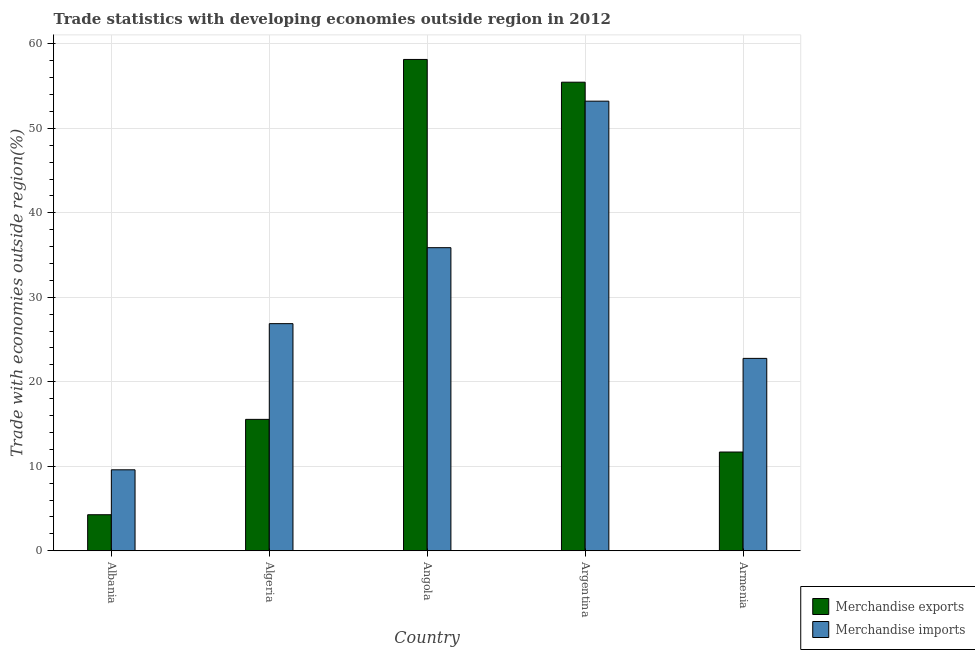Are the number of bars per tick equal to the number of legend labels?
Your answer should be compact. Yes. Are the number of bars on each tick of the X-axis equal?
Ensure brevity in your answer.  Yes. How many bars are there on the 4th tick from the left?
Offer a terse response. 2. What is the label of the 3rd group of bars from the left?
Give a very brief answer. Angola. What is the merchandise exports in Angola?
Your answer should be very brief. 58.15. Across all countries, what is the maximum merchandise exports?
Keep it short and to the point. 58.15. Across all countries, what is the minimum merchandise imports?
Your answer should be very brief. 9.58. In which country was the merchandise exports maximum?
Offer a very short reply. Angola. In which country was the merchandise imports minimum?
Provide a short and direct response. Albania. What is the total merchandise imports in the graph?
Keep it short and to the point. 148.32. What is the difference between the merchandise exports in Albania and that in Armenia?
Ensure brevity in your answer.  -7.42. What is the difference between the merchandise exports in Albania and the merchandise imports in Armenia?
Your answer should be compact. -18.5. What is the average merchandise imports per country?
Keep it short and to the point. 29.66. What is the difference between the merchandise exports and merchandise imports in Albania?
Your response must be concise. -5.32. In how many countries, is the merchandise exports greater than 22 %?
Provide a short and direct response. 2. What is the ratio of the merchandise exports in Angola to that in Argentina?
Offer a terse response. 1.05. Is the merchandise exports in Argentina less than that in Armenia?
Keep it short and to the point. No. Is the difference between the merchandise imports in Algeria and Argentina greater than the difference between the merchandise exports in Algeria and Argentina?
Provide a succinct answer. Yes. What is the difference between the highest and the second highest merchandise exports?
Your response must be concise. 2.69. What is the difference between the highest and the lowest merchandise imports?
Offer a very short reply. 43.63. Is the sum of the merchandise imports in Angola and Argentina greater than the maximum merchandise exports across all countries?
Ensure brevity in your answer.  Yes. How many countries are there in the graph?
Your answer should be compact. 5. What is the difference between two consecutive major ticks on the Y-axis?
Provide a succinct answer. 10. Are the values on the major ticks of Y-axis written in scientific E-notation?
Make the answer very short. No. Does the graph contain any zero values?
Give a very brief answer. No. Where does the legend appear in the graph?
Keep it short and to the point. Bottom right. How many legend labels are there?
Provide a succinct answer. 2. How are the legend labels stacked?
Make the answer very short. Vertical. What is the title of the graph?
Your response must be concise. Trade statistics with developing economies outside region in 2012. Does "Underweight" appear as one of the legend labels in the graph?
Ensure brevity in your answer.  No. What is the label or title of the X-axis?
Offer a terse response. Country. What is the label or title of the Y-axis?
Provide a short and direct response. Trade with economies outside region(%). What is the Trade with economies outside region(%) in Merchandise exports in Albania?
Give a very brief answer. 4.27. What is the Trade with economies outside region(%) of Merchandise imports in Albania?
Your response must be concise. 9.58. What is the Trade with economies outside region(%) in Merchandise exports in Algeria?
Your response must be concise. 15.55. What is the Trade with economies outside region(%) of Merchandise imports in Algeria?
Provide a succinct answer. 26.88. What is the Trade with economies outside region(%) in Merchandise exports in Angola?
Ensure brevity in your answer.  58.15. What is the Trade with economies outside region(%) of Merchandise imports in Angola?
Offer a terse response. 35.87. What is the Trade with economies outside region(%) of Merchandise exports in Argentina?
Ensure brevity in your answer.  55.46. What is the Trade with economies outside region(%) in Merchandise imports in Argentina?
Keep it short and to the point. 53.21. What is the Trade with economies outside region(%) of Merchandise exports in Armenia?
Give a very brief answer. 11.69. What is the Trade with economies outside region(%) of Merchandise imports in Armenia?
Provide a short and direct response. 22.77. Across all countries, what is the maximum Trade with economies outside region(%) in Merchandise exports?
Offer a terse response. 58.15. Across all countries, what is the maximum Trade with economies outside region(%) of Merchandise imports?
Keep it short and to the point. 53.21. Across all countries, what is the minimum Trade with economies outside region(%) of Merchandise exports?
Your answer should be very brief. 4.27. Across all countries, what is the minimum Trade with economies outside region(%) of Merchandise imports?
Make the answer very short. 9.58. What is the total Trade with economies outside region(%) of Merchandise exports in the graph?
Keep it short and to the point. 145.11. What is the total Trade with economies outside region(%) in Merchandise imports in the graph?
Your answer should be compact. 148.32. What is the difference between the Trade with economies outside region(%) of Merchandise exports in Albania and that in Algeria?
Provide a succinct answer. -11.29. What is the difference between the Trade with economies outside region(%) of Merchandise imports in Albania and that in Algeria?
Provide a succinct answer. -17.3. What is the difference between the Trade with economies outside region(%) in Merchandise exports in Albania and that in Angola?
Your response must be concise. -53.88. What is the difference between the Trade with economies outside region(%) of Merchandise imports in Albania and that in Angola?
Your answer should be very brief. -26.29. What is the difference between the Trade with economies outside region(%) of Merchandise exports in Albania and that in Argentina?
Ensure brevity in your answer.  -51.19. What is the difference between the Trade with economies outside region(%) of Merchandise imports in Albania and that in Argentina?
Provide a short and direct response. -43.63. What is the difference between the Trade with economies outside region(%) of Merchandise exports in Albania and that in Armenia?
Offer a terse response. -7.42. What is the difference between the Trade with economies outside region(%) in Merchandise imports in Albania and that in Armenia?
Your answer should be compact. -13.19. What is the difference between the Trade with economies outside region(%) in Merchandise exports in Algeria and that in Angola?
Offer a very short reply. -42.6. What is the difference between the Trade with economies outside region(%) in Merchandise imports in Algeria and that in Angola?
Your answer should be very brief. -8.99. What is the difference between the Trade with economies outside region(%) in Merchandise exports in Algeria and that in Argentina?
Make the answer very short. -39.91. What is the difference between the Trade with economies outside region(%) in Merchandise imports in Algeria and that in Argentina?
Your answer should be very brief. -26.33. What is the difference between the Trade with economies outside region(%) in Merchandise exports in Algeria and that in Armenia?
Offer a very short reply. 3.86. What is the difference between the Trade with economies outside region(%) in Merchandise imports in Algeria and that in Armenia?
Your response must be concise. 4.11. What is the difference between the Trade with economies outside region(%) of Merchandise exports in Angola and that in Argentina?
Your response must be concise. 2.69. What is the difference between the Trade with economies outside region(%) in Merchandise imports in Angola and that in Argentina?
Give a very brief answer. -17.34. What is the difference between the Trade with economies outside region(%) of Merchandise exports in Angola and that in Armenia?
Provide a short and direct response. 46.46. What is the difference between the Trade with economies outside region(%) in Merchandise imports in Angola and that in Armenia?
Your answer should be very brief. 13.1. What is the difference between the Trade with economies outside region(%) of Merchandise exports in Argentina and that in Armenia?
Provide a succinct answer. 43.77. What is the difference between the Trade with economies outside region(%) in Merchandise imports in Argentina and that in Armenia?
Make the answer very short. 30.44. What is the difference between the Trade with economies outside region(%) in Merchandise exports in Albania and the Trade with economies outside region(%) in Merchandise imports in Algeria?
Your response must be concise. -22.61. What is the difference between the Trade with economies outside region(%) of Merchandise exports in Albania and the Trade with economies outside region(%) of Merchandise imports in Angola?
Give a very brief answer. -31.61. What is the difference between the Trade with economies outside region(%) in Merchandise exports in Albania and the Trade with economies outside region(%) in Merchandise imports in Argentina?
Your response must be concise. -48.95. What is the difference between the Trade with economies outside region(%) of Merchandise exports in Albania and the Trade with economies outside region(%) of Merchandise imports in Armenia?
Make the answer very short. -18.5. What is the difference between the Trade with economies outside region(%) in Merchandise exports in Algeria and the Trade with economies outside region(%) in Merchandise imports in Angola?
Your response must be concise. -20.32. What is the difference between the Trade with economies outside region(%) of Merchandise exports in Algeria and the Trade with economies outside region(%) of Merchandise imports in Argentina?
Your answer should be very brief. -37.66. What is the difference between the Trade with economies outside region(%) of Merchandise exports in Algeria and the Trade with economies outside region(%) of Merchandise imports in Armenia?
Ensure brevity in your answer.  -7.22. What is the difference between the Trade with economies outside region(%) of Merchandise exports in Angola and the Trade with economies outside region(%) of Merchandise imports in Argentina?
Provide a succinct answer. 4.94. What is the difference between the Trade with economies outside region(%) in Merchandise exports in Angola and the Trade with economies outside region(%) in Merchandise imports in Armenia?
Your answer should be compact. 35.38. What is the difference between the Trade with economies outside region(%) of Merchandise exports in Argentina and the Trade with economies outside region(%) of Merchandise imports in Armenia?
Ensure brevity in your answer.  32.69. What is the average Trade with economies outside region(%) in Merchandise exports per country?
Offer a very short reply. 29.02. What is the average Trade with economies outside region(%) in Merchandise imports per country?
Keep it short and to the point. 29.66. What is the difference between the Trade with economies outside region(%) in Merchandise exports and Trade with economies outside region(%) in Merchandise imports in Albania?
Your response must be concise. -5.32. What is the difference between the Trade with economies outside region(%) of Merchandise exports and Trade with economies outside region(%) of Merchandise imports in Algeria?
Your answer should be compact. -11.33. What is the difference between the Trade with economies outside region(%) in Merchandise exports and Trade with economies outside region(%) in Merchandise imports in Angola?
Your answer should be compact. 22.28. What is the difference between the Trade with economies outside region(%) of Merchandise exports and Trade with economies outside region(%) of Merchandise imports in Argentina?
Your answer should be compact. 2.25. What is the difference between the Trade with economies outside region(%) of Merchandise exports and Trade with economies outside region(%) of Merchandise imports in Armenia?
Make the answer very short. -11.08. What is the ratio of the Trade with economies outside region(%) of Merchandise exports in Albania to that in Algeria?
Offer a very short reply. 0.27. What is the ratio of the Trade with economies outside region(%) of Merchandise imports in Albania to that in Algeria?
Keep it short and to the point. 0.36. What is the ratio of the Trade with economies outside region(%) in Merchandise exports in Albania to that in Angola?
Ensure brevity in your answer.  0.07. What is the ratio of the Trade with economies outside region(%) in Merchandise imports in Albania to that in Angola?
Your answer should be compact. 0.27. What is the ratio of the Trade with economies outside region(%) in Merchandise exports in Albania to that in Argentina?
Ensure brevity in your answer.  0.08. What is the ratio of the Trade with economies outside region(%) of Merchandise imports in Albania to that in Argentina?
Your answer should be compact. 0.18. What is the ratio of the Trade with economies outside region(%) in Merchandise exports in Albania to that in Armenia?
Offer a very short reply. 0.36. What is the ratio of the Trade with economies outside region(%) of Merchandise imports in Albania to that in Armenia?
Your response must be concise. 0.42. What is the ratio of the Trade with economies outside region(%) of Merchandise exports in Algeria to that in Angola?
Provide a succinct answer. 0.27. What is the ratio of the Trade with economies outside region(%) of Merchandise imports in Algeria to that in Angola?
Provide a succinct answer. 0.75. What is the ratio of the Trade with economies outside region(%) of Merchandise exports in Algeria to that in Argentina?
Your response must be concise. 0.28. What is the ratio of the Trade with economies outside region(%) in Merchandise imports in Algeria to that in Argentina?
Your answer should be very brief. 0.51. What is the ratio of the Trade with economies outside region(%) in Merchandise exports in Algeria to that in Armenia?
Make the answer very short. 1.33. What is the ratio of the Trade with economies outside region(%) in Merchandise imports in Algeria to that in Armenia?
Ensure brevity in your answer.  1.18. What is the ratio of the Trade with economies outside region(%) of Merchandise exports in Angola to that in Argentina?
Your response must be concise. 1.05. What is the ratio of the Trade with economies outside region(%) in Merchandise imports in Angola to that in Argentina?
Your answer should be very brief. 0.67. What is the ratio of the Trade with economies outside region(%) in Merchandise exports in Angola to that in Armenia?
Your answer should be very brief. 4.98. What is the ratio of the Trade with economies outside region(%) of Merchandise imports in Angola to that in Armenia?
Offer a terse response. 1.58. What is the ratio of the Trade with economies outside region(%) in Merchandise exports in Argentina to that in Armenia?
Offer a terse response. 4.74. What is the ratio of the Trade with economies outside region(%) in Merchandise imports in Argentina to that in Armenia?
Keep it short and to the point. 2.34. What is the difference between the highest and the second highest Trade with economies outside region(%) of Merchandise exports?
Your answer should be compact. 2.69. What is the difference between the highest and the second highest Trade with economies outside region(%) in Merchandise imports?
Offer a terse response. 17.34. What is the difference between the highest and the lowest Trade with economies outside region(%) of Merchandise exports?
Provide a succinct answer. 53.88. What is the difference between the highest and the lowest Trade with economies outside region(%) in Merchandise imports?
Ensure brevity in your answer.  43.63. 